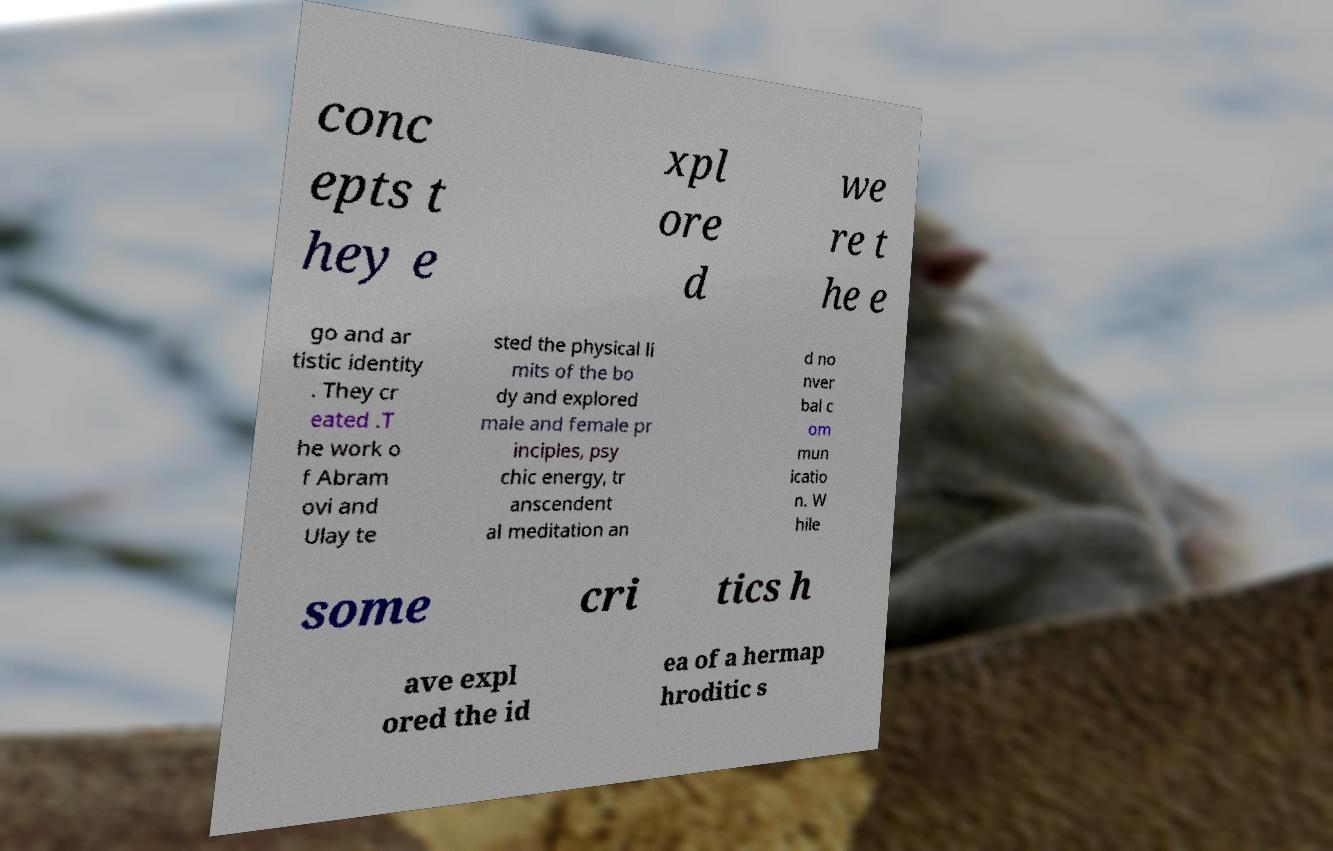Please identify and transcribe the text found in this image. conc epts t hey e xpl ore d we re t he e go and ar tistic identity . They cr eated .T he work o f Abram ovi and Ulay te sted the physical li mits of the bo dy and explored male and female pr inciples, psy chic energy, tr anscendent al meditation an d no nver bal c om mun icatio n. W hile some cri tics h ave expl ored the id ea of a hermap hroditic s 